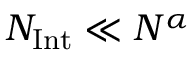<formula> <loc_0><loc_0><loc_500><loc_500>N _ { I n t } \ll { N ^ { \alpha } }</formula> 